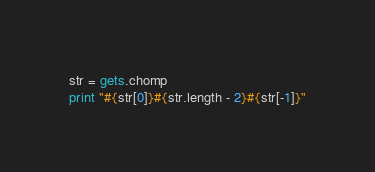<code> <loc_0><loc_0><loc_500><loc_500><_Ruby_>str = gets.chomp
print "#{str[0]}#{str.length - 2}#{str[-1]}"</code> 